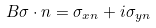<formula> <loc_0><loc_0><loc_500><loc_500>\ B { \sigma } \cdot n = \sigma _ { x n } + i \sigma _ { y n }</formula> 